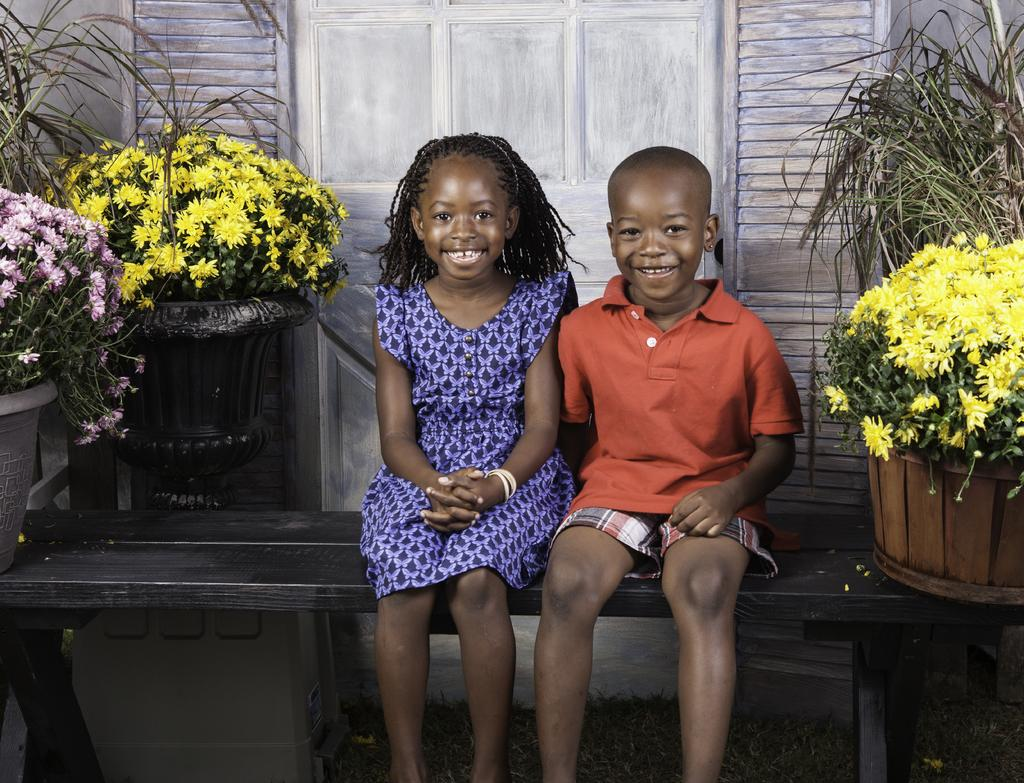How many children are present in the image? There are two children in the image. What are the children doing in the image? The children are sitting on a table and smiling. What else can be seen in the image besides the children? There are flower pots in the image. What type of food is the children eating in the image? There is no food visible in the image, as the children are sitting on a table and smiling, but no food is mentioned or shown. 